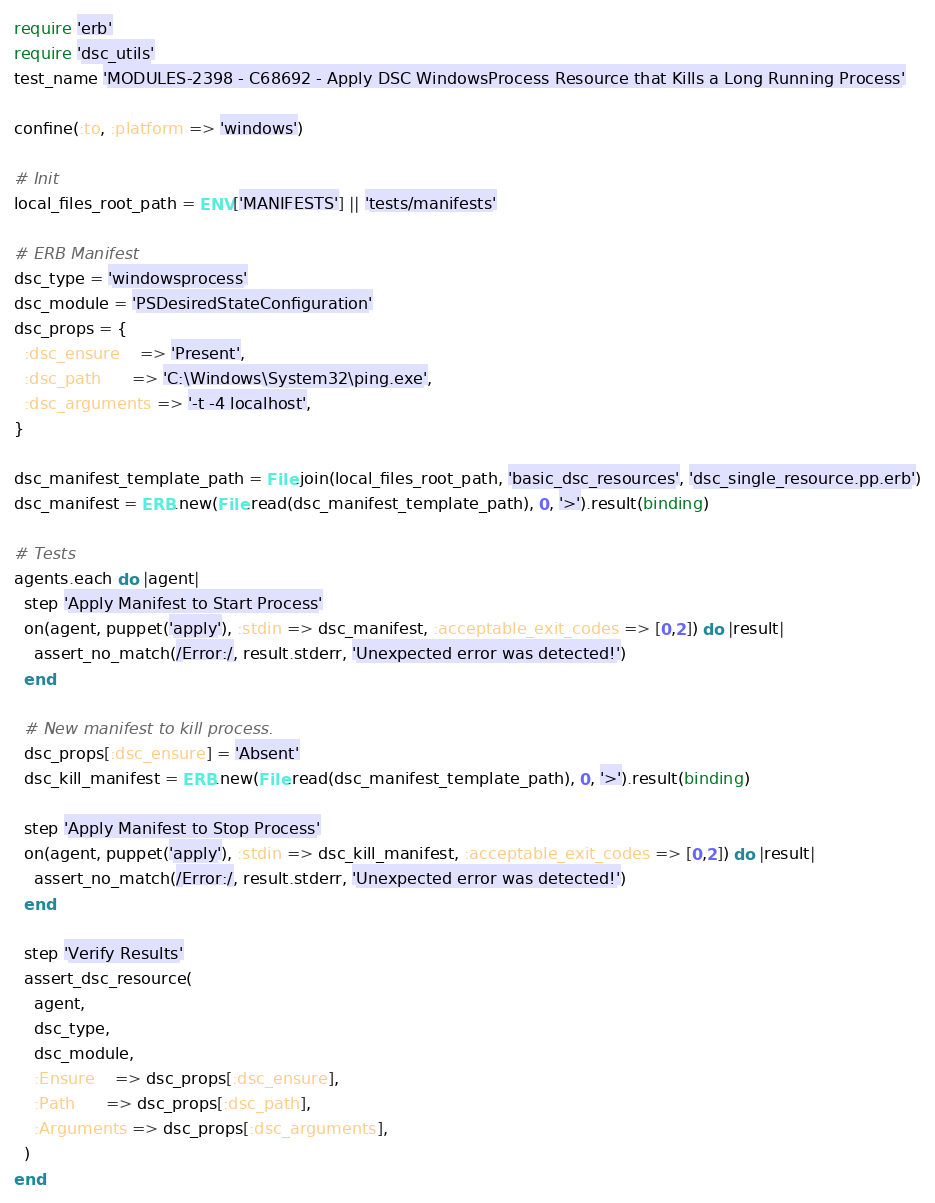Convert code to text. <code><loc_0><loc_0><loc_500><loc_500><_Ruby_>require 'erb'
require 'dsc_utils'
test_name 'MODULES-2398 - C68692 - Apply DSC WindowsProcess Resource that Kills a Long Running Process'

confine(:to, :platform => 'windows')

# Init
local_files_root_path = ENV['MANIFESTS'] || 'tests/manifests'

# ERB Manifest
dsc_type = 'windowsprocess'
dsc_module = 'PSDesiredStateConfiguration'
dsc_props = {
  :dsc_ensure    => 'Present',
  :dsc_path      => 'C:\Windows\System32\ping.exe',
  :dsc_arguments => '-t -4 localhost',
}

dsc_manifest_template_path = File.join(local_files_root_path, 'basic_dsc_resources', 'dsc_single_resource.pp.erb')
dsc_manifest = ERB.new(File.read(dsc_manifest_template_path), 0, '>').result(binding)

# Tests
agents.each do |agent|
  step 'Apply Manifest to Start Process'
  on(agent, puppet('apply'), :stdin => dsc_manifest, :acceptable_exit_codes => [0,2]) do |result|
    assert_no_match(/Error:/, result.stderr, 'Unexpected error was detected!')
  end

  # New manifest to kill process.
  dsc_props[:dsc_ensure] = 'Absent'
  dsc_kill_manifest = ERB.new(File.read(dsc_manifest_template_path), 0, '>').result(binding)

  step 'Apply Manifest to Stop Process'
  on(agent, puppet('apply'), :stdin => dsc_kill_manifest, :acceptable_exit_codes => [0,2]) do |result|
    assert_no_match(/Error:/, result.stderr, 'Unexpected error was detected!')
  end

  step 'Verify Results'
  assert_dsc_resource(
    agent,
    dsc_type,
    dsc_module,
    :Ensure    => dsc_props[:dsc_ensure],
    :Path      => dsc_props[:dsc_path],
    :Arguments => dsc_props[:dsc_arguments],
  )
end
</code> 